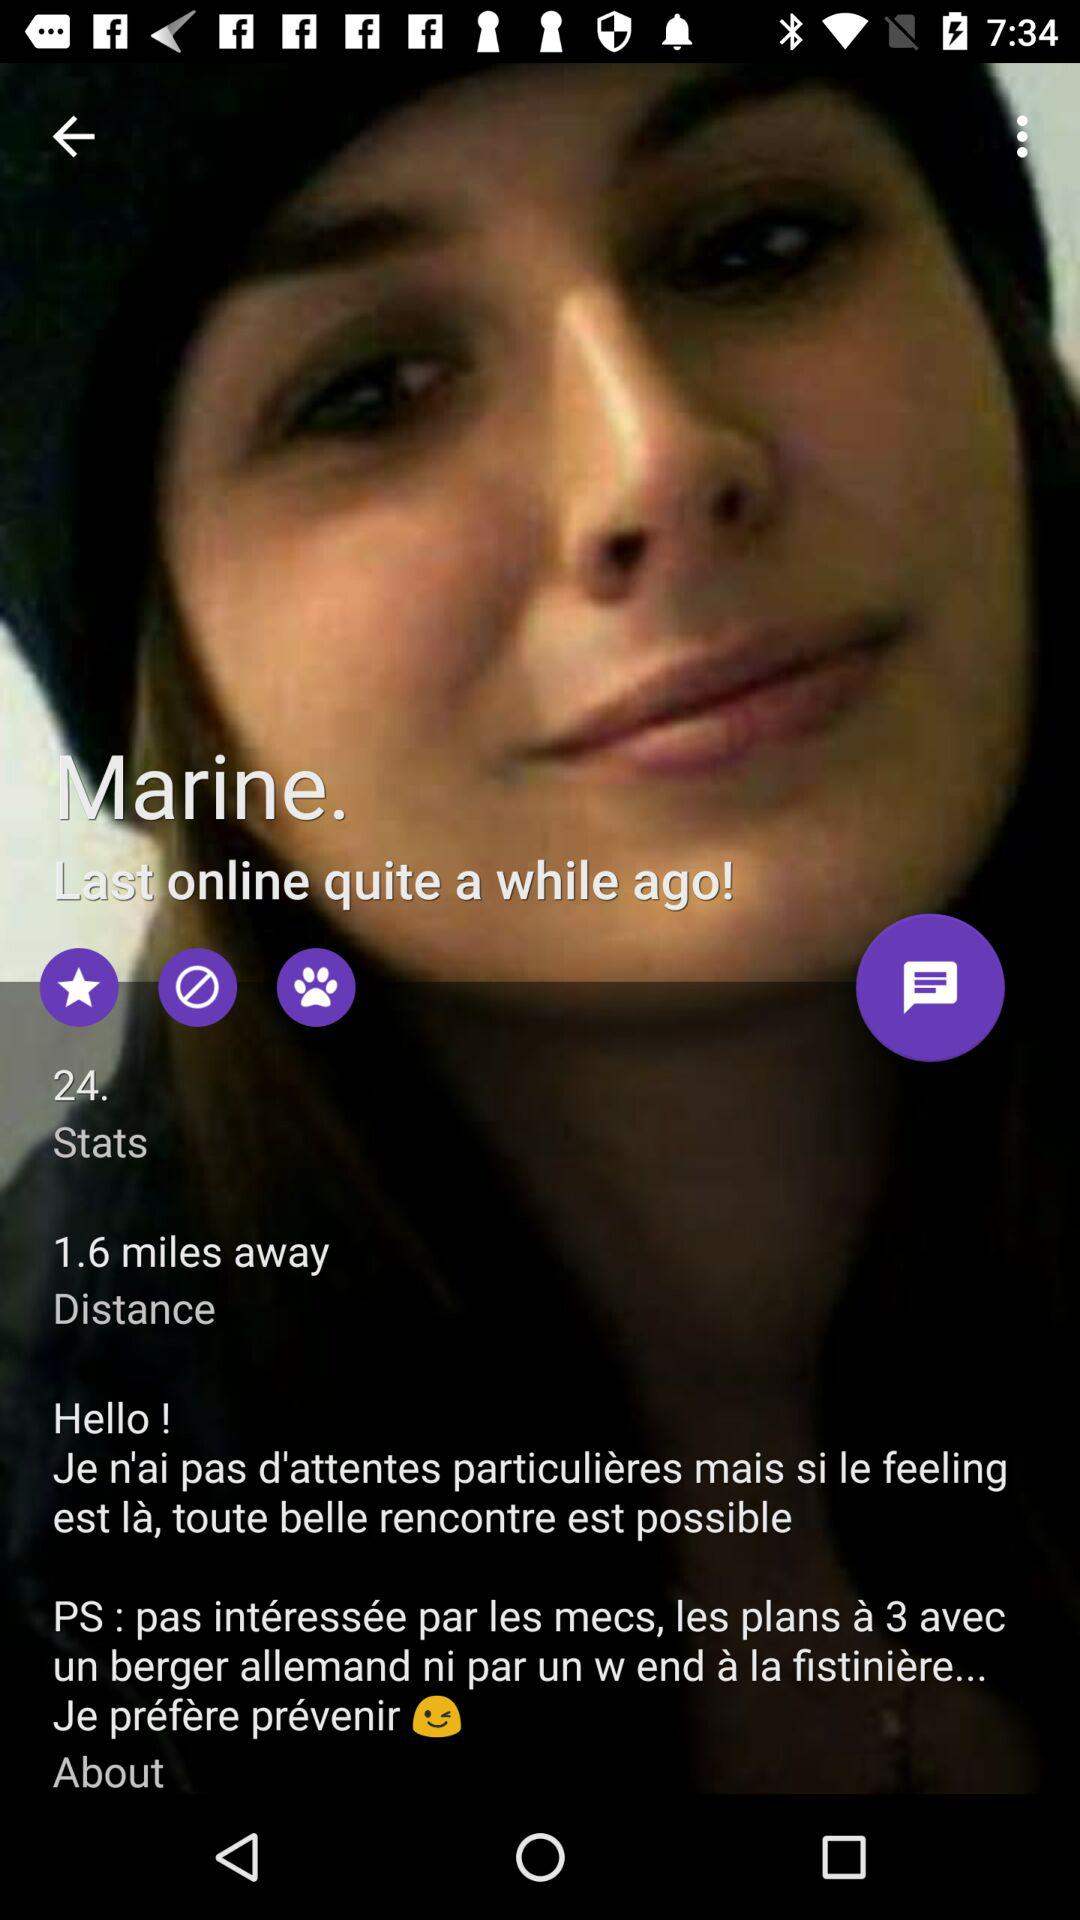How many stars are showing?
When the provided information is insufficient, respond with <no answer>. <no answer> 